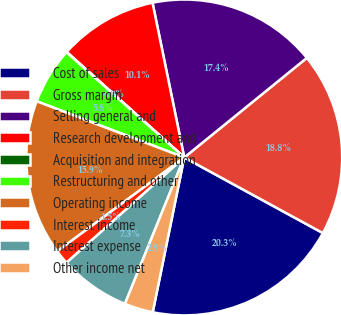Convert chart to OTSL. <chart><loc_0><loc_0><loc_500><loc_500><pie_chart><fcel>Cost of sales<fcel>Gross margin<fcel>Selling general and<fcel>Research development and<fcel>Acquisition and integration<fcel>Restructuring and other<fcel>Operating income<fcel>Interest income<fcel>Interest expense<fcel>Other income net<nl><fcel>20.25%<fcel>18.8%<fcel>17.36%<fcel>10.14%<fcel>0.04%<fcel>5.81%<fcel>15.92%<fcel>1.48%<fcel>7.26%<fcel>2.93%<nl></chart> 